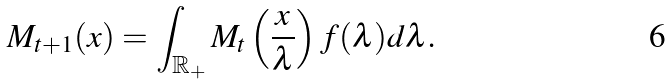<formula> <loc_0><loc_0><loc_500><loc_500>M _ { t + 1 } ( x ) = \int _ { \mathbb { R } _ { + } } M _ { t } \left ( \frac { x } { \lambda } \right ) f ( \lambda ) d \lambda .</formula> 